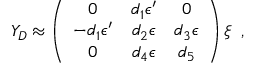Convert formula to latex. <formula><loc_0><loc_0><loc_500><loc_500>Y _ { D } \approx \left ( \begin{array} { c c c } { 0 } & { { d _ { 1 } \epsilon ^ { \prime } } } & { 0 } \\ { { - d _ { 1 } \epsilon ^ { \prime } } } & { { d _ { 2 } \epsilon } } & { { d _ { 3 } \epsilon } } \\ { 0 } & { { d _ { 4 } \epsilon } } & { { d _ { 5 } } } \end{array} \right ) \xi \, ,</formula> 